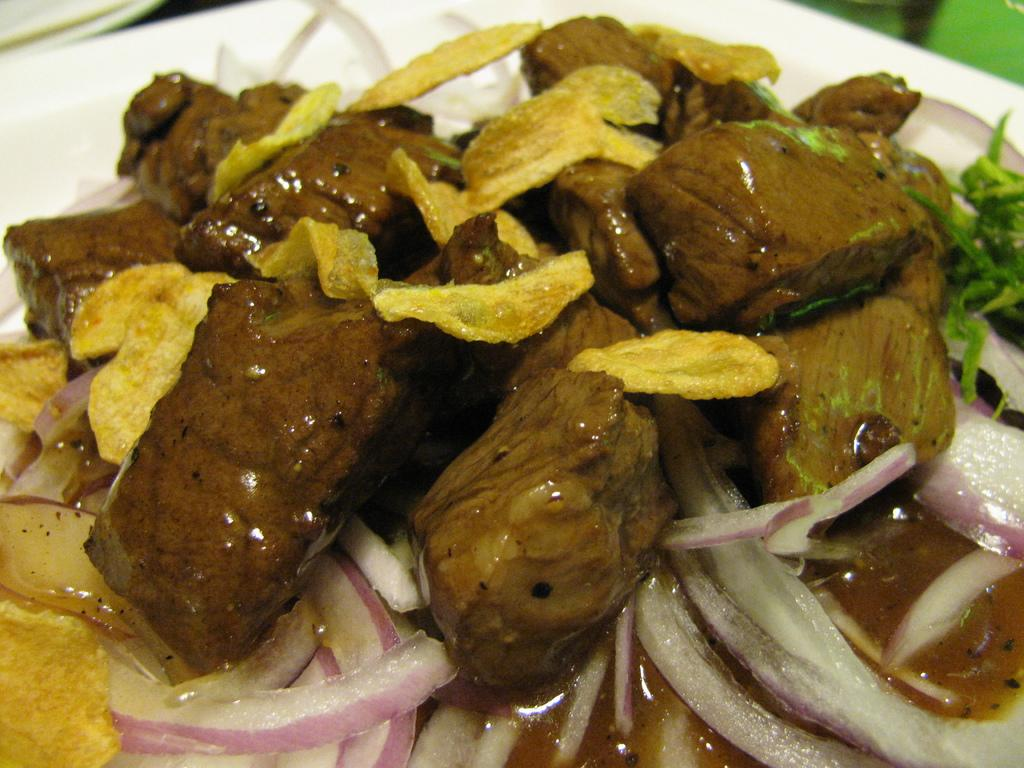What type of food is visible in the image? There are pieces of chicken in the image. How are the chicken pieces prepared? The chicken pieces are dipped in a sauce and have crisps on them. What other ingredient can be seen on the chicken pieces? There is onion on the chicken pieces. Where are the chicken pieces placed? The chicken pieces are on a plate. Is there a bridge visible in the image? No, there is no bridge present in the image. Are there any stockings or beetles visible in the image? No, there are no stockings or beetles present in the image. 